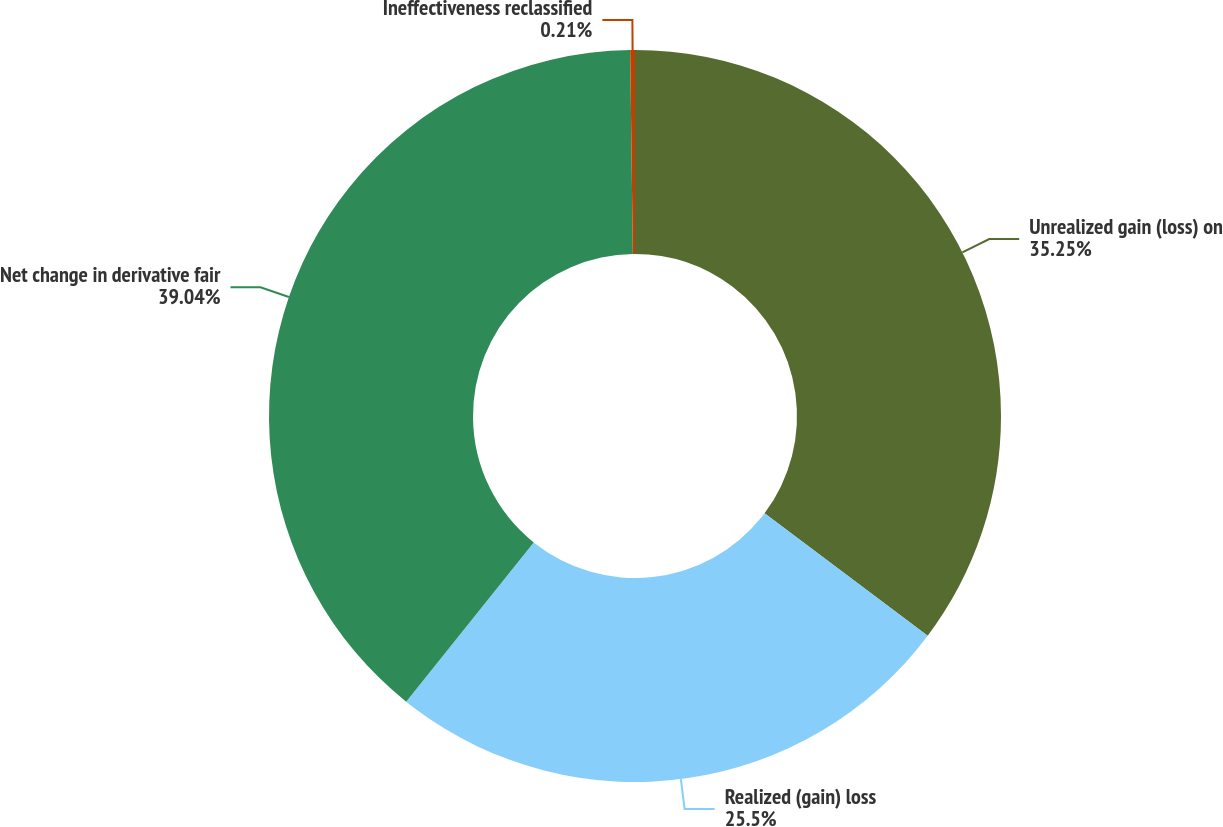Convert chart to OTSL. <chart><loc_0><loc_0><loc_500><loc_500><pie_chart><fcel>Unrealized gain (loss) on<fcel>Realized (gain) loss<fcel>Net change in derivative fair<fcel>Ineffectiveness reclassified<nl><fcel>35.25%<fcel>25.5%<fcel>39.04%<fcel>0.21%<nl></chart> 